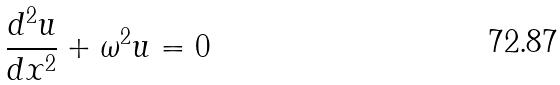<formula> <loc_0><loc_0><loc_500><loc_500>\frac { d ^ { 2 } u } { d x ^ { 2 } } + \omega ^ { 2 } u = 0</formula> 